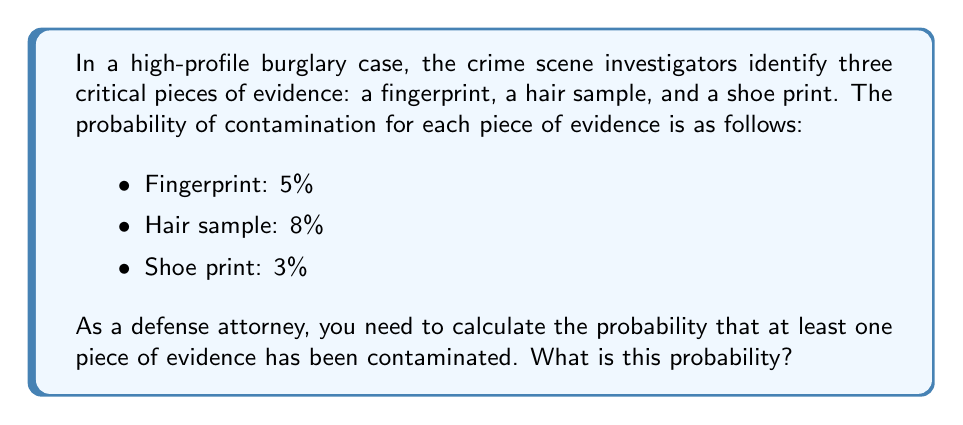Can you answer this question? To solve this problem, we'll use the concept of probability of the complement event. Instead of directly calculating the probability of at least one piece of evidence being contaminated, we'll calculate the probability that none of the evidence is contaminated and then subtract that from 1.

Let's break it down step-by-step:

1) First, we need to calculate the probability that each piece of evidence is not contaminated:
   - Fingerprint: $1 - 0.05 = 0.95$ (95% chance of no contamination)
   - Hair sample: $1 - 0.08 = 0.92$ (92% chance of no contamination)
   - Shoe print: $1 - 0.03 = 0.97$ (97% chance of no contamination)

2) The probability that all pieces of evidence are not contaminated is the product of these individual probabilities:

   $P(\text{no contamination}) = 0.95 \times 0.92 \times 0.97 = 0.8468$ (84.68%)

3) Therefore, the probability that at least one piece of evidence is contaminated is the complement of this probability:

   $P(\text{at least one contaminated}) = 1 - P(\text{no contamination})$
   $= 1 - 0.8468 = 0.1532$

4) Converting to a percentage:
   $0.1532 \times 100\% = 15.32\%$

Thus, there is a 15.32% chance that at least one piece of evidence has been contaminated.
Answer: 15.32% 